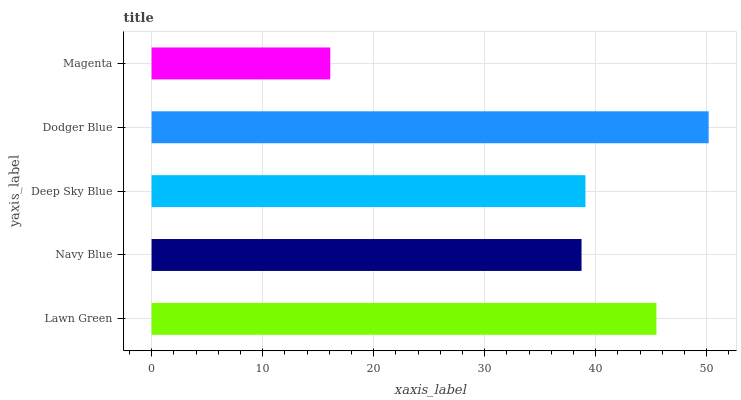Is Magenta the minimum?
Answer yes or no. Yes. Is Dodger Blue the maximum?
Answer yes or no. Yes. Is Navy Blue the minimum?
Answer yes or no. No. Is Navy Blue the maximum?
Answer yes or no. No. Is Lawn Green greater than Navy Blue?
Answer yes or no. Yes. Is Navy Blue less than Lawn Green?
Answer yes or no. Yes. Is Navy Blue greater than Lawn Green?
Answer yes or no. No. Is Lawn Green less than Navy Blue?
Answer yes or no. No. Is Deep Sky Blue the high median?
Answer yes or no. Yes. Is Deep Sky Blue the low median?
Answer yes or no. Yes. Is Navy Blue the high median?
Answer yes or no. No. Is Dodger Blue the low median?
Answer yes or no. No. 